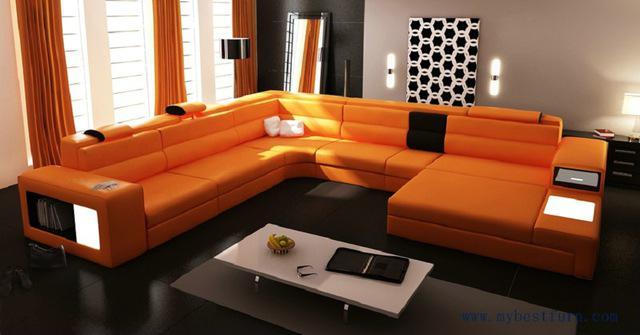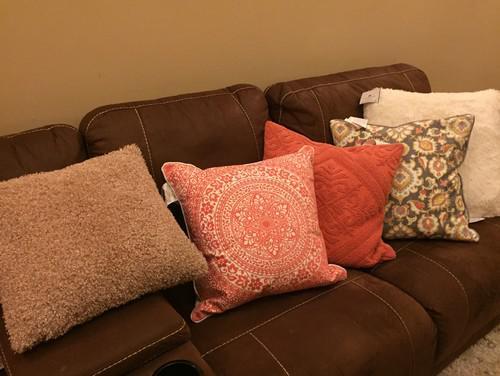The first image is the image on the left, the second image is the image on the right. For the images displayed, is the sentence "The pillows on one of the images are sitting on a brown couch." factually correct? Answer yes or no. Yes. The first image is the image on the left, the second image is the image on the right. Evaluate the accuracy of this statement regarding the images: "One room includes an orange sectional couch that forms a corner, in front of hanging orange drapes.". Is it true? Answer yes or no. Yes. 